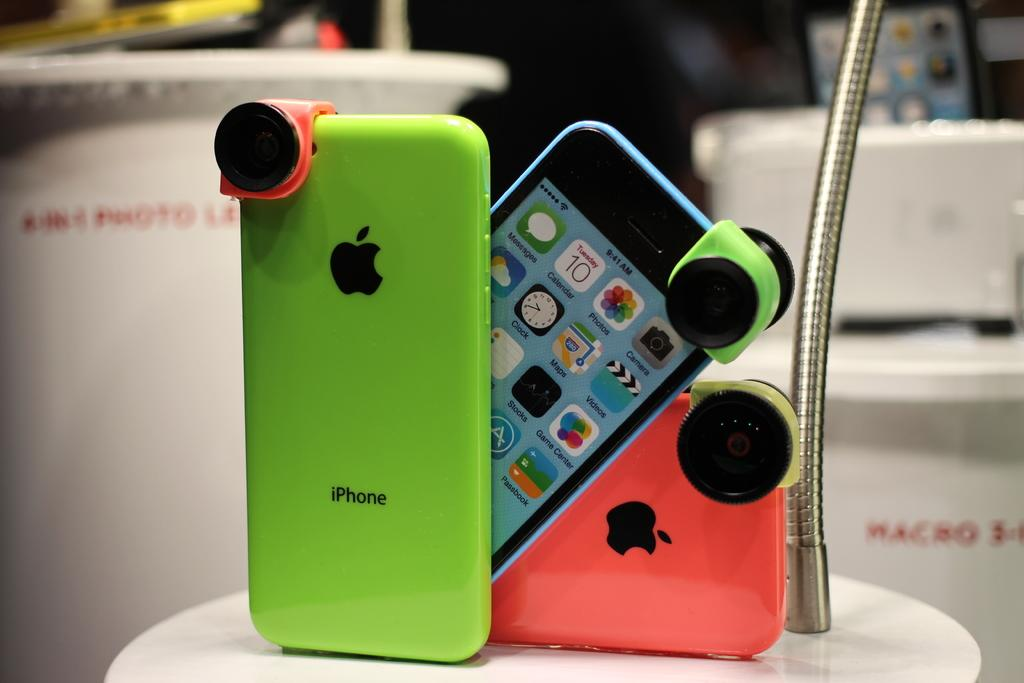Provide a one-sentence caption for the provided image. The brighly colored iPhones are on display at the store. 